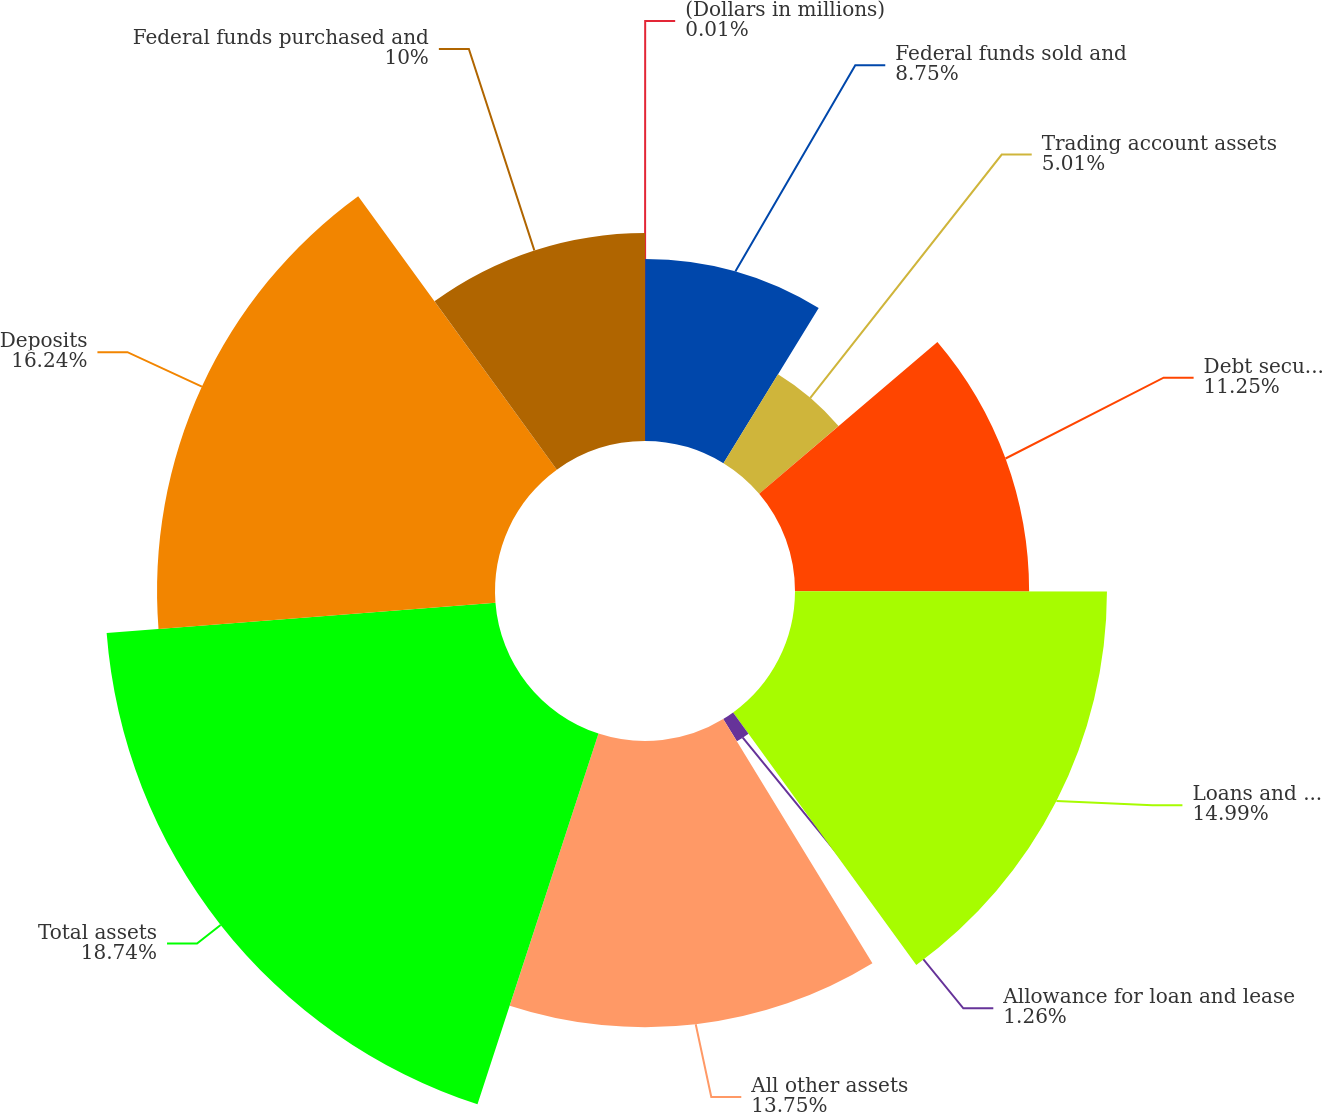Convert chart to OTSL. <chart><loc_0><loc_0><loc_500><loc_500><pie_chart><fcel>(Dollars in millions)<fcel>Federal funds sold and<fcel>Trading account assets<fcel>Debt securities<fcel>Loans and leases<fcel>Allowance for loan and lease<fcel>All other assets<fcel>Total assets<fcel>Deposits<fcel>Federal funds purchased and<nl><fcel>0.01%<fcel>8.75%<fcel>5.01%<fcel>11.25%<fcel>14.99%<fcel>1.26%<fcel>13.75%<fcel>18.74%<fcel>16.24%<fcel>10.0%<nl></chart> 